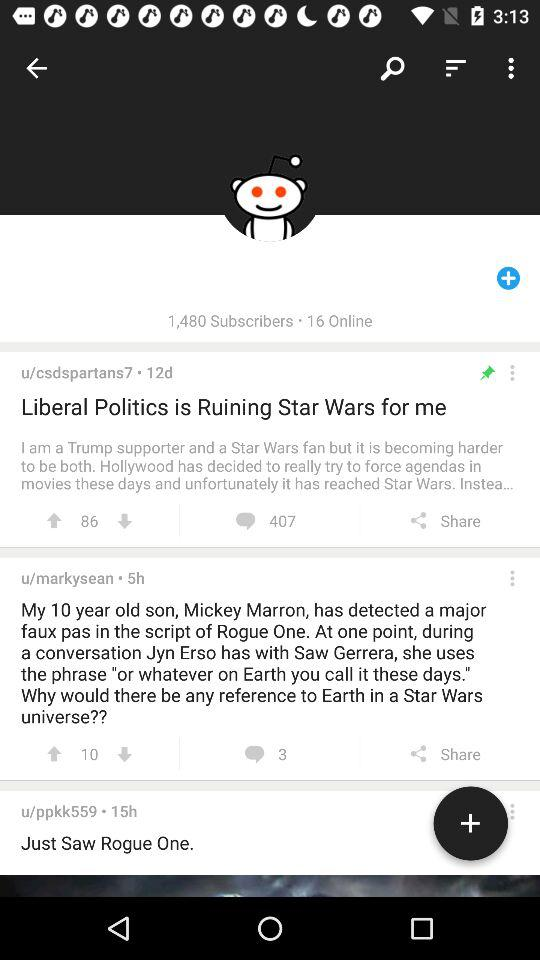What is the number of subscribers? The number of subscribers is 1,480. 